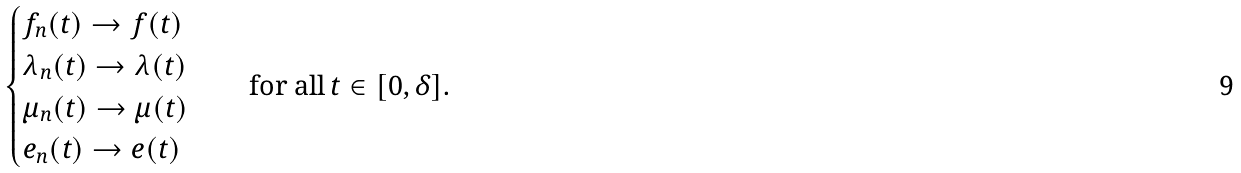Convert formula to latex. <formula><loc_0><loc_0><loc_500><loc_500>\begin{cases} f _ { n } ( t ) \rightarrow f ( t ) \\ \lambda _ { n } ( t ) \rightarrow \lambda ( t ) \\ \mu _ { n } ( t ) \rightarrow \mu ( t ) \\ e _ { n } ( t ) \rightarrow e ( t ) \end{cases} \quad \text {for all} \, t \in [ 0 , \delta ] .</formula> 